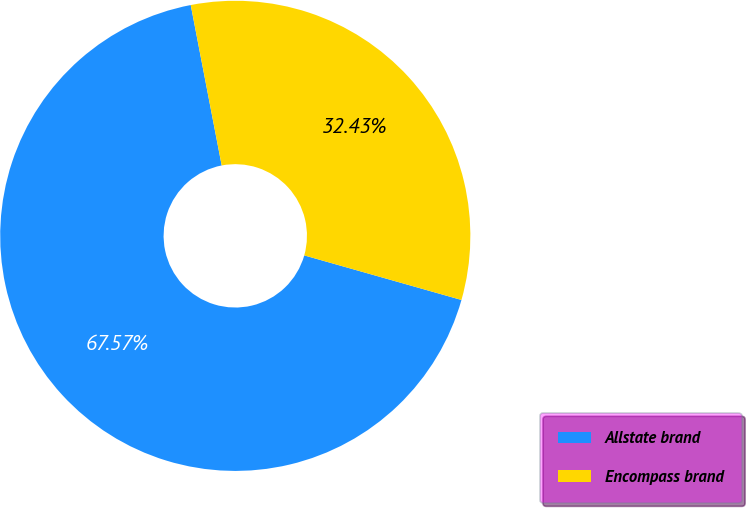Convert chart. <chart><loc_0><loc_0><loc_500><loc_500><pie_chart><fcel>Allstate brand<fcel>Encompass brand<nl><fcel>67.57%<fcel>32.43%<nl></chart> 